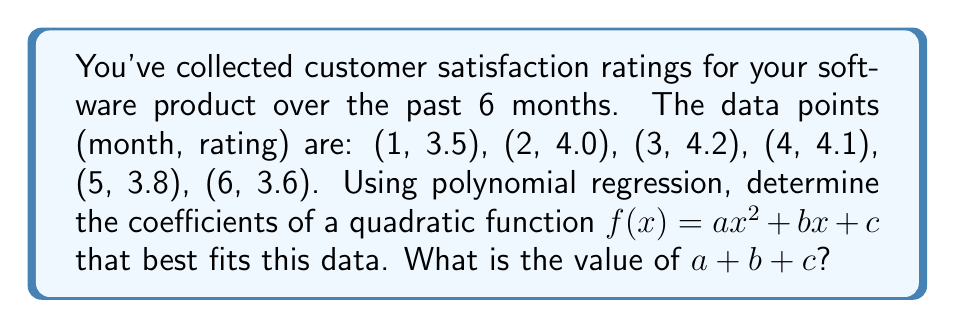Show me your answer to this math problem. To solve this problem, we'll use the least squares method for polynomial regression:

1. Set up the system of equations:
   $$\begin{aligned}
   \sum x^4 a + \sum x^3 b + \sum x^2 c &= \sum x^2 y \\
   \sum x^3 a + \sum x^2 b + \sum x c &= \sum x y \\
   \sum x^2 a + \sum x b + n c &= \sum y
   \end{aligned}$$

2. Calculate the sums:
   $$\begin{aligned}
   \sum x^4 &= 1^4 + 2^4 + 3^4 + 4^4 + 5^4 + 6^4 = 979 \\
   \sum x^3 &= 1^3 + 2^3 + 3^3 + 4^3 + 5^3 + 6^3 = 441 \\
   \sum x^2 &= 1^2 + 2^2 + 3^2 + 4^2 + 5^2 + 6^2 = 91 \\
   \sum x &= 1 + 2 + 3 + 4 + 5 + 6 = 21 \\
   n &= 6 \\
   \sum y &= 3.5 + 4.0 + 4.2 + 4.1 + 3.8 + 3.6 = 23.2 \\
   \sum x^2 y &= 1^2(3.5) + 2^2(4.0) + 3^2(4.2) + 4^2(4.1) + 5^2(3.8) + 6^2(3.6) = 364.9 \\
   \sum x y &= 1(3.5) + 2(4.0) + 3(4.2) + 4(4.1) + 5(3.8) + 6(3.6) = 85.0
   \end{aligned}$$

3. Substitute into the system of equations:
   $$\begin{aligned}
   979a + 441b + 91c &= 364.9 \\
   441a + 91b + 21c &= 85.0 \\
   91a + 21b + 6c &= 23.2
   \end{aligned}$$

4. Solve the system of equations (using a calculator or computer algebra system):
   $$\begin{aligned}
   a &= -0.0833 \\
   b &= 0.6500 \\
   c &= 2.9333
   \end{aligned}$$

5. Calculate $a + b + c$:
   $$a + b + c = -0.0833 + 0.6500 + 2.9333 = 3.5000$$
Answer: 3.5000 